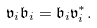Convert formula to latex. <formula><loc_0><loc_0><loc_500><loc_500>\mathfrak v _ { i } \mathfrak b _ { i } = \mathfrak b _ { i } \mathfrak v _ { i } ^ { * } .</formula> 